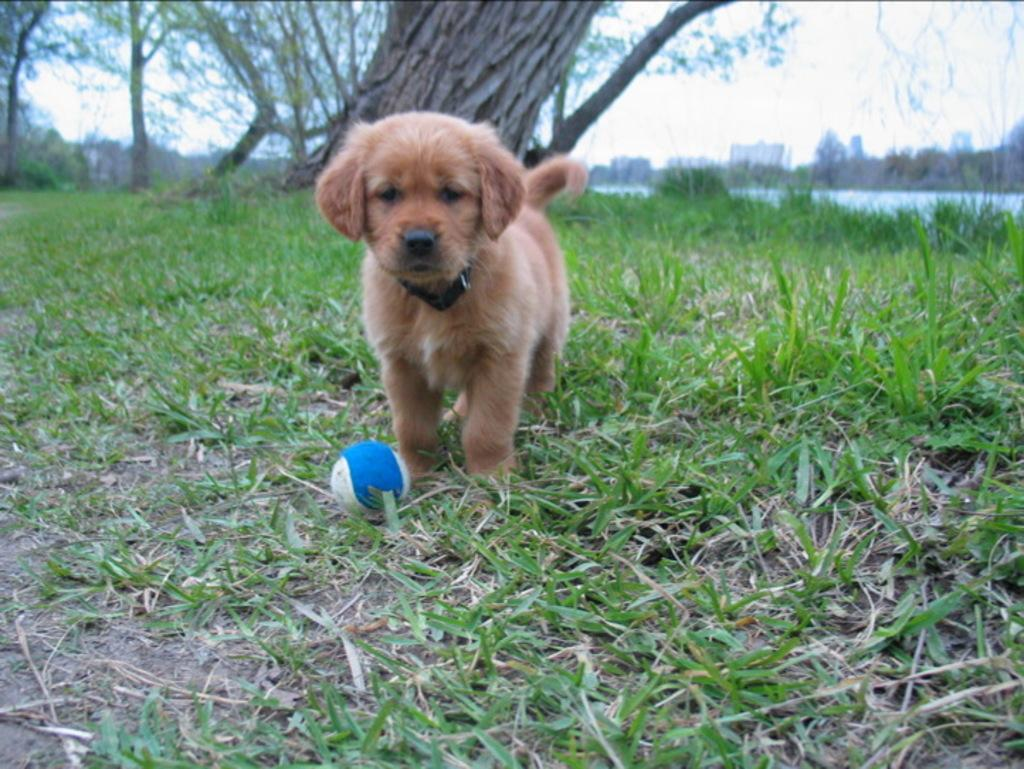What type of animal is in the image? There is a dog in the image. What color is the dog? The dog is brown in color. Where is the dog located? The dog is on the grass. What object is in front of the dog? There is a ball in front of the dog. What can be seen in the background of the image? Trees, water, and the sky are visible in the background of the image. Can you see a kite flying in the image? There is no kite visible in the image. How many bees are buzzing around the dog in the image? There are no bees present in the image. 